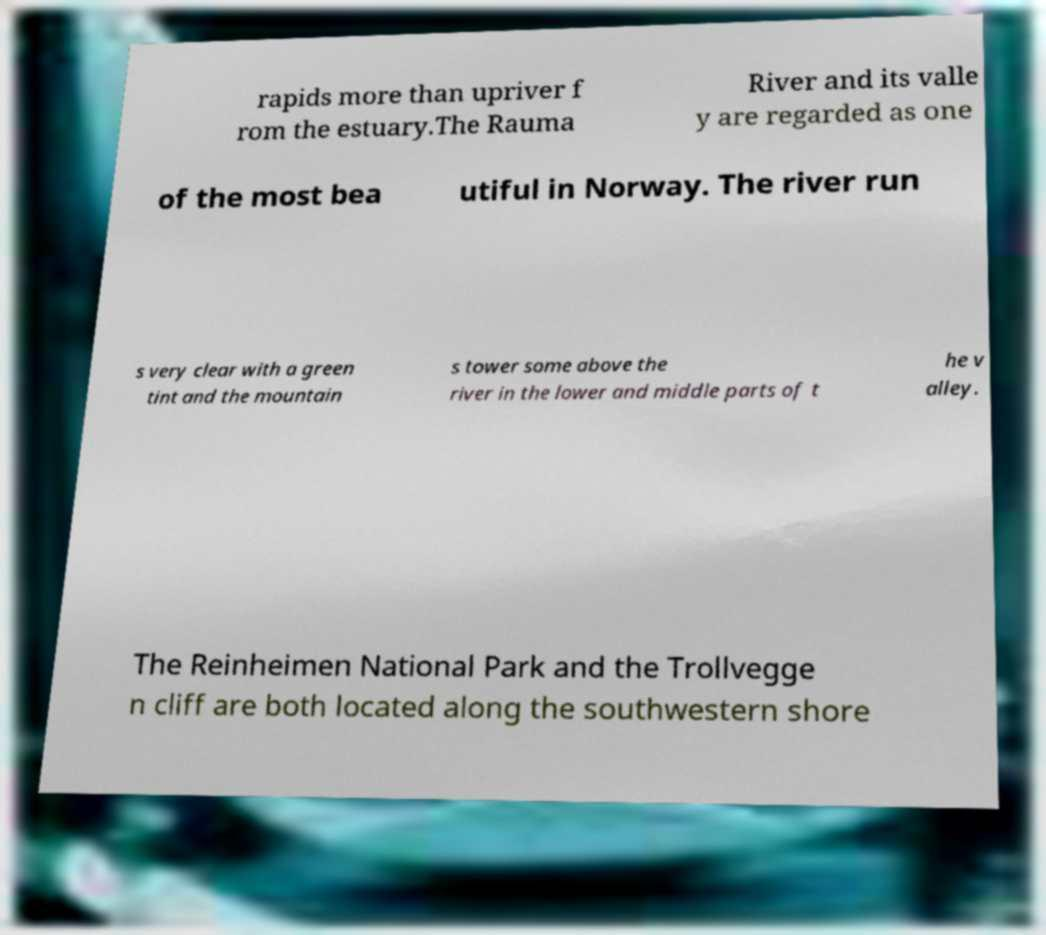Please identify and transcribe the text found in this image. rapids more than upriver f rom the estuary.The Rauma River and its valle y are regarded as one of the most bea utiful in Norway. The river run s very clear with a green tint and the mountain s tower some above the river in the lower and middle parts of t he v alley. The Reinheimen National Park and the Trollvegge n cliff are both located along the southwestern shore 